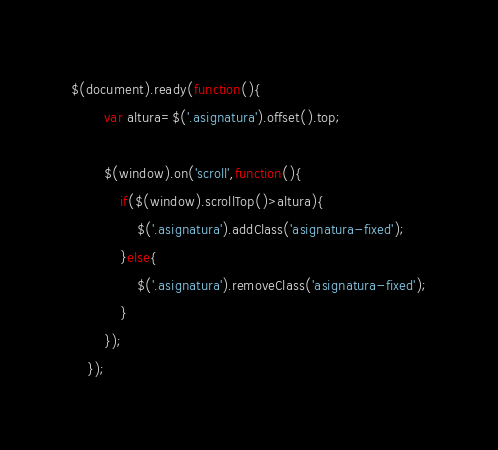Convert code to text. <code><loc_0><loc_0><loc_500><loc_500><_JavaScript_>$(document).ready(function(){
		var altura=$('.asignatura').offset().top;

		$(window).on('scroll',function(){
			if($(window).scrollTop()>altura){
				$('.asignatura').addClass('asignatura-fixed');
			}else{
				$('.asignatura').removeClass('asignatura-fixed');
			}
		});
	});</code> 